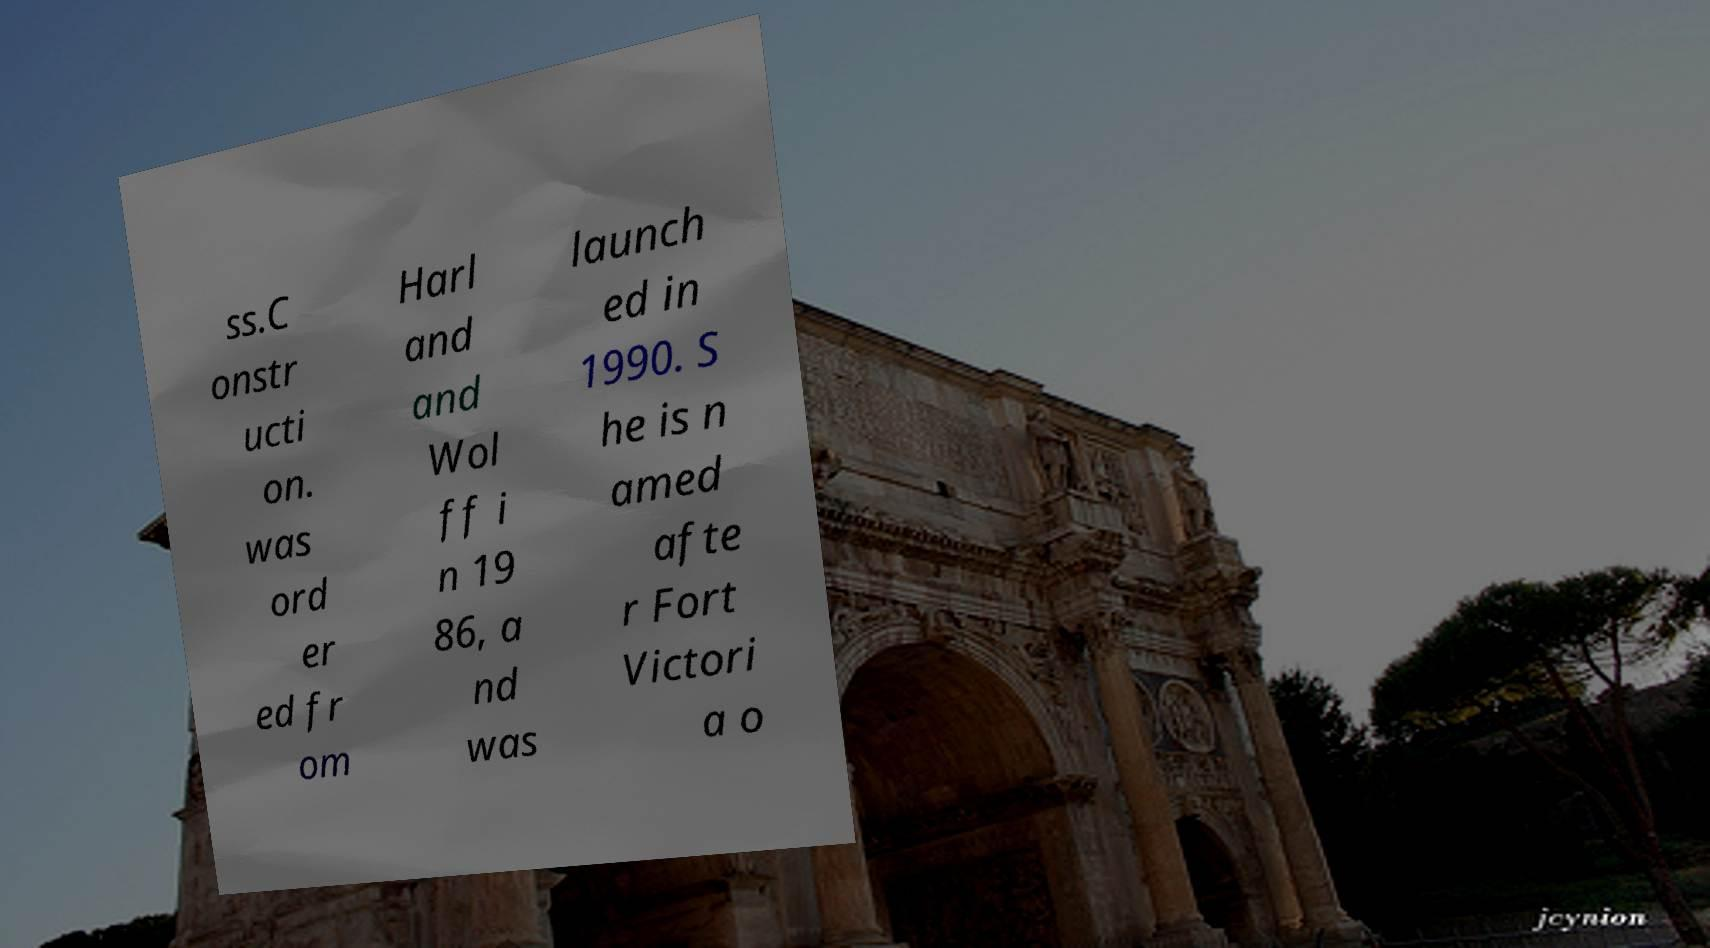Can you accurately transcribe the text from the provided image for me? ss.C onstr ucti on. was ord er ed fr om Harl and and Wol ff i n 19 86, a nd was launch ed in 1990. S he is n amed afte r Fort Victori a o 